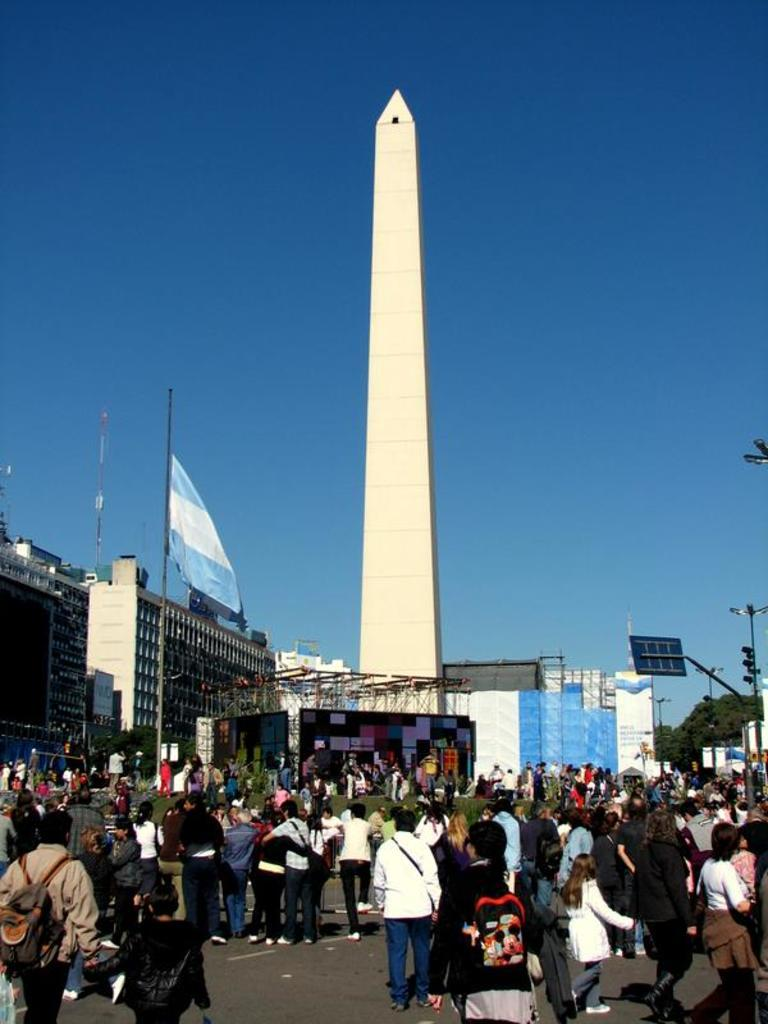How many people are in the image? There are people in the image, but the exact number is not specified. What are the people wearing that resemble bags? Some of the people are wearing bags in the image. What type of structures can be seen in the image? There are buildings, a traffic light, a solar panel, poles, and a tower in the image. What is visible in the sky in the image? The sky is visible in the image. What type of device is present in the image? There is a screen in the image. What type of tooth is visible in the image? There is no tooth present in the image. What suggestion is being made by the people in the image? The facts provided do not give any information about a suggestion being made by the people in the image. 